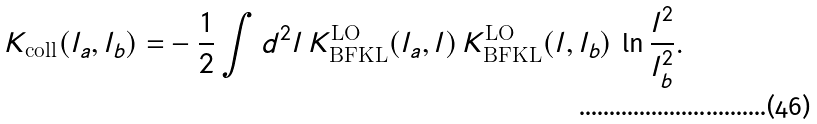Convert formula to latex. <formula><loc_0><loc_0><loc_500><loc_500>K _ { \text {coll} } ( { l } _ { a } , { l } _ { b } ) = & - \frac { 1 } { 2 } \int d ^ { 2 } { l } \, K ^ { \text {LO} } _ { \text {BFKL} } ( { l } _ { a } , { l } ) \, K ^ { \text {LO} } _ { \text {BFKL} } ( { l } , { l } _ { b } ) \, \ln { \frac { { l } ^ { 2 } } { { l } _ { b } ^ { 2 } } } .</formula> 